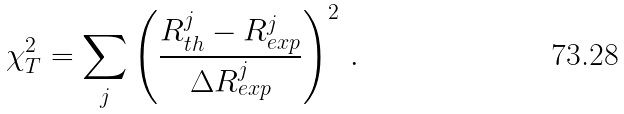<formula> <loc_0><loc_0><loc_500><loc_500>\chi _ { T } ^ { 2 } = \sum _ { j } \left ( \frac { R _ { t h } ^ { j } - R _ { e x p } ^ { j } } { { \Delta R _ { e x p } ^ { j } } } \right ) ^ { 2 } \, .</formula> 